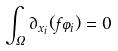Convert formula to latex. <formula><loc_0><loc_0><loc_500><loc_500>\int _ { \Omega } \partial _ { x _ { i } } ( f \varphi _ { i } ) = 0</formula> 